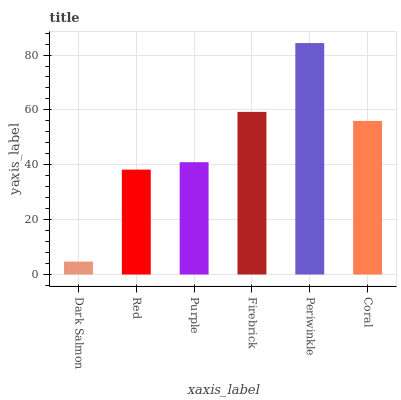Is Dark Salmon the minimum?
Answer yes or no. Yes. Is Periwinkle the maximum?
Answer yes or no. Yes. Is Red the minimum?
Answer yes or no. No. Is Red the maximum?
Answer yes or no. No. Is Red greater than Dark Salmon?
Answer yes or no. Yes. Is Dark Salmon less than Red?
Answer yes or no. Yes. Is Dark Salmon greater than Red?
Answer yes or no. No. Is Red less than Dark Salmon?
Answer yes or no. No. Is Coral the high median?
Answer yes or no. Yes. Is Purple the low median?
Answer yes or no. Yes. Is Red the high median?
Answer yes or no. No. Is Periwinkle the low median?
Answer yes or no. No. 